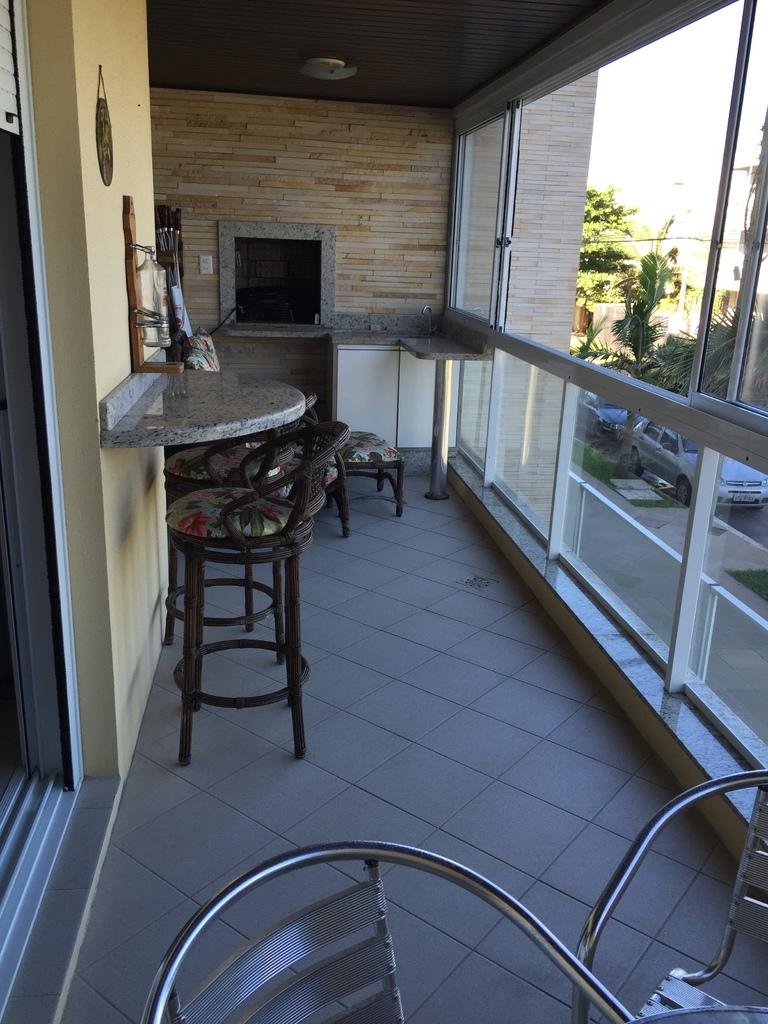What type of furniture is present in the image? There are chairs in the image. What can be seen in the distance in the image? There is a car visible in the background of the image. What type of natural elements are present in the background of the image? There are trees in the background of the image. What type of iron is being used by the grandmother in the image? There is no grandmother or iron present in the image. 